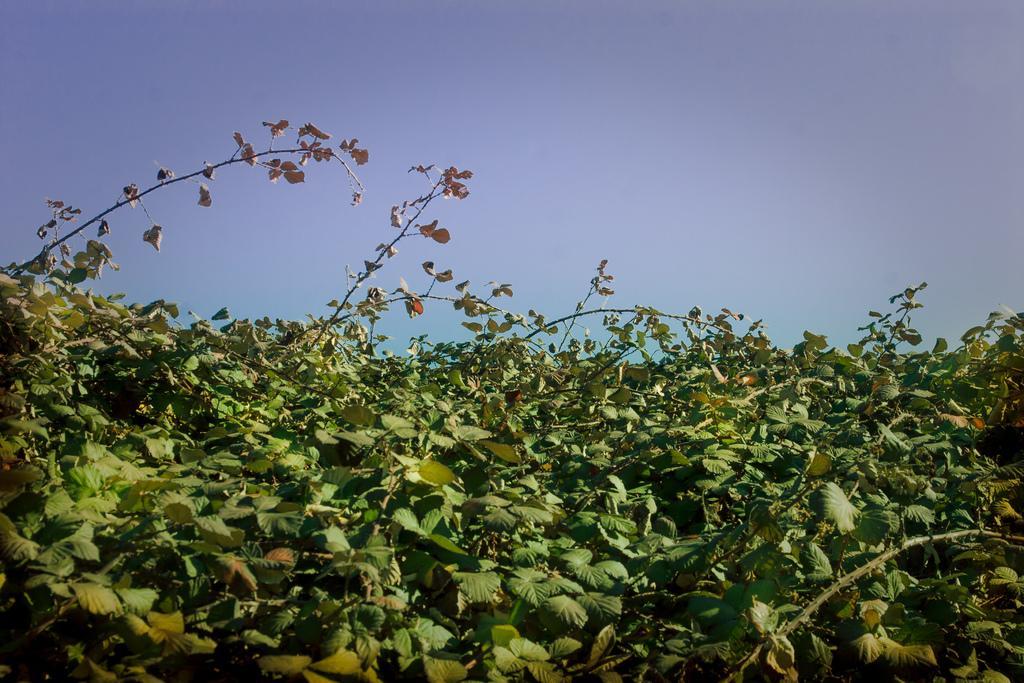Could you give a brief overview of what you see in this image? In this image, I can see the trees with branches and leaves. This is the sky. 